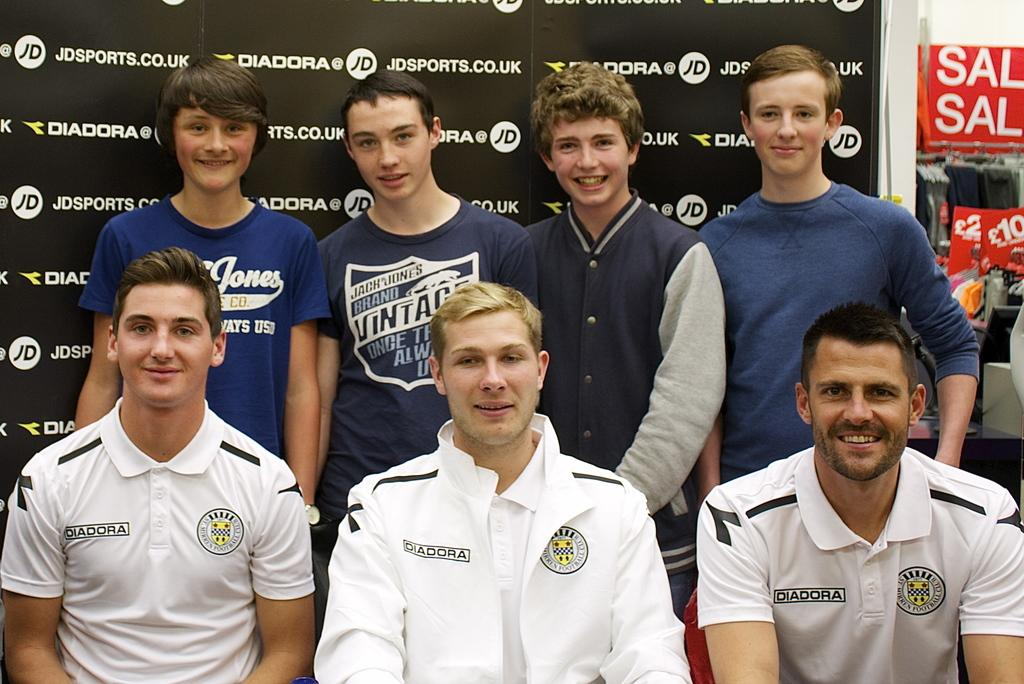Provide a one-sentence caption for the provided image. a person that wears a vintage shirt that is blue. 